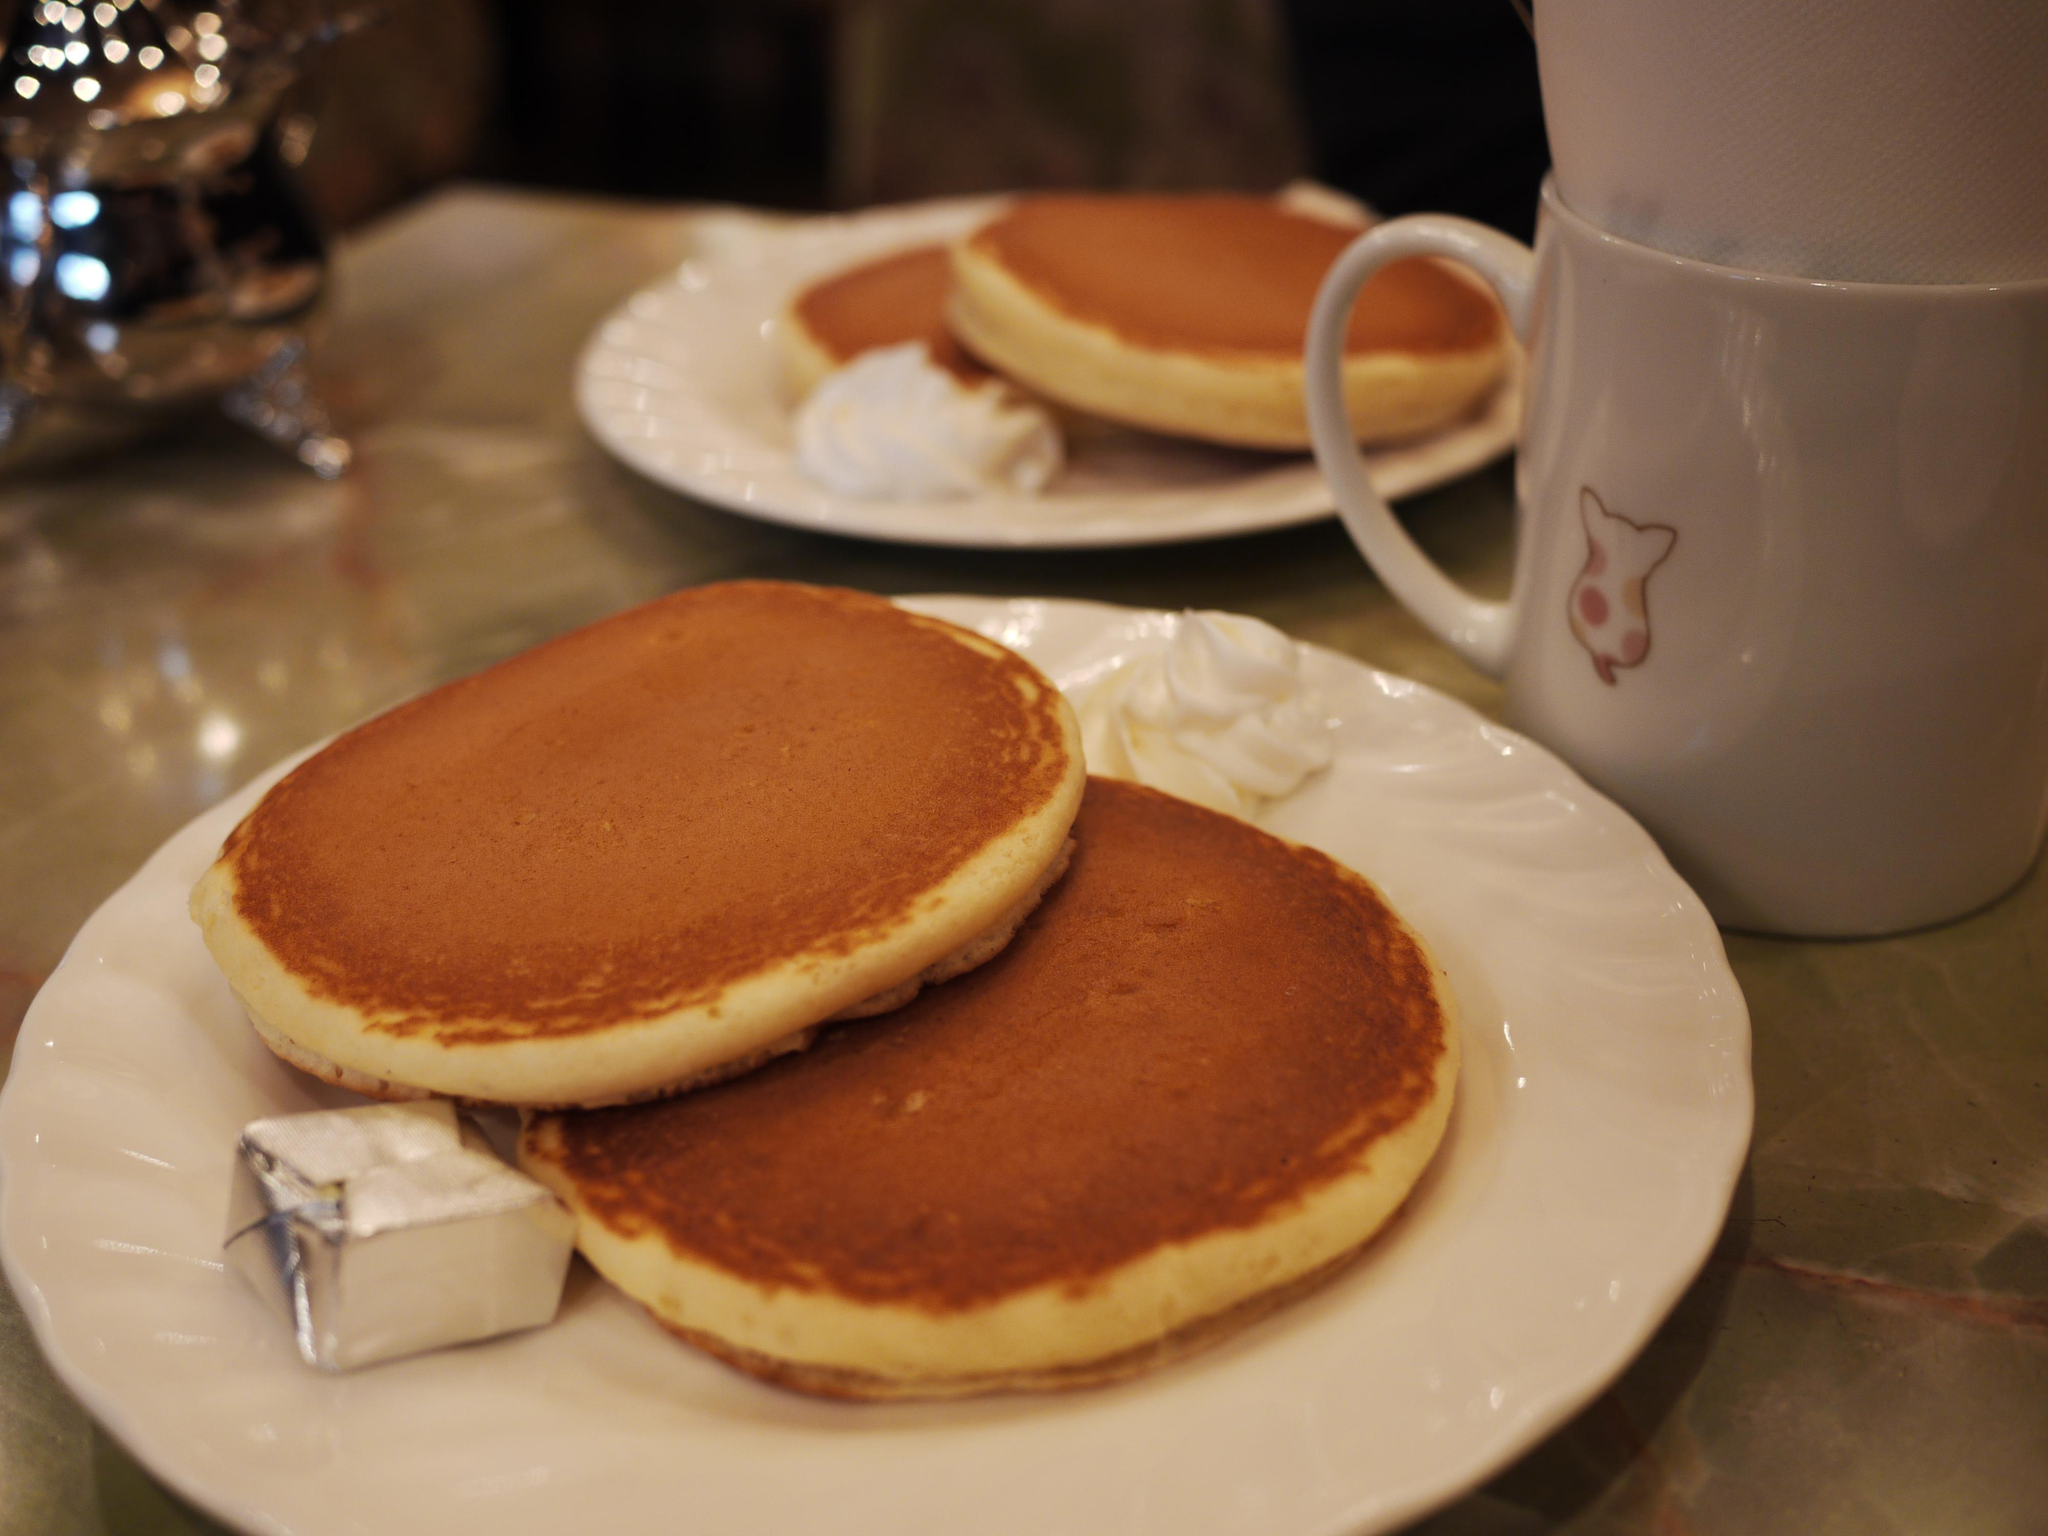What is the main piece of furniture in the image? There is a table in the image. What can be found on the table? There are cups and plates containing desserts on the table. Are there any other objects on the table? Yes, there are other objects on the table. What is the lighting condition at the top of the image? The top of the image is dark. What year is depicted in the image? The image does not depict a specific year; it is a still image of a table with various objects on it. What type of trade is being conducted in the image? There is no trade being conducted in the image; it is a still image of a table with various objects on it. 